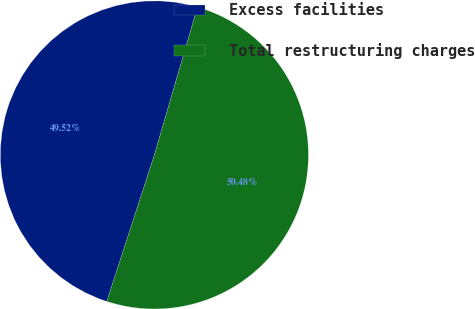<chart> <loc_0><loc_0><loc_500><loc_500><pie_chart><fcel>Excess facilities<fcel>Total restructuring charges<nl><fcel>49.52%<fcel>50.48%<nl></chart> 